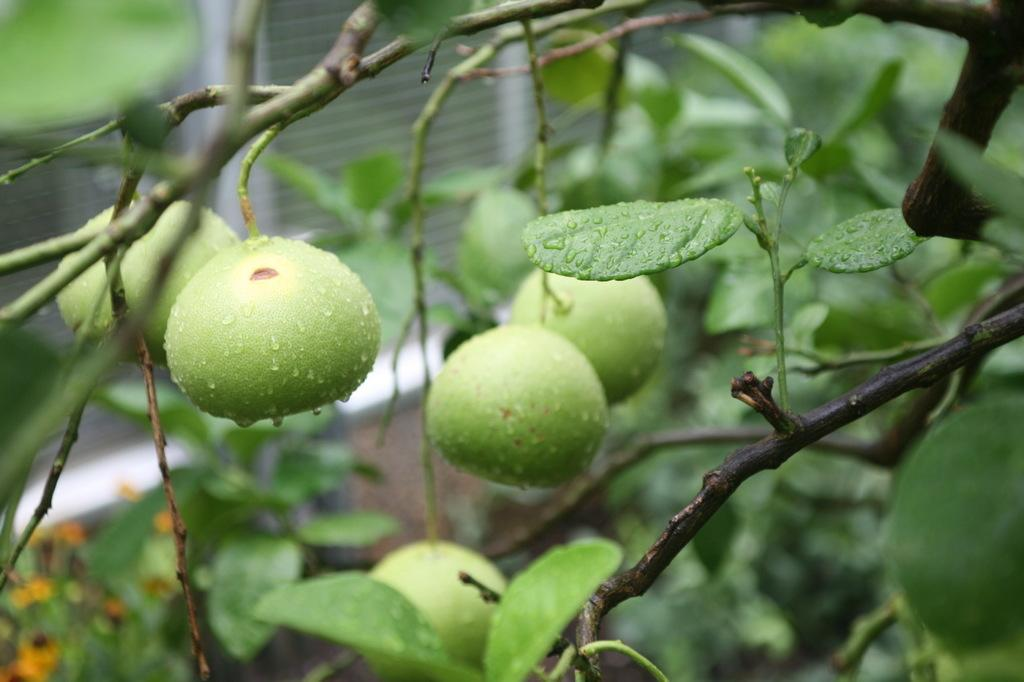What type of tree is present in the image? There is a tree with fruits in the image. What can be observed about the tree's foliage? The tree has leaves. Can you describe the background of the image? The background of the image is blurred. What is the price of the discovery made by the tree in the image? There is no discovery mentioned in the image, and therefore no price can be associated with it. 